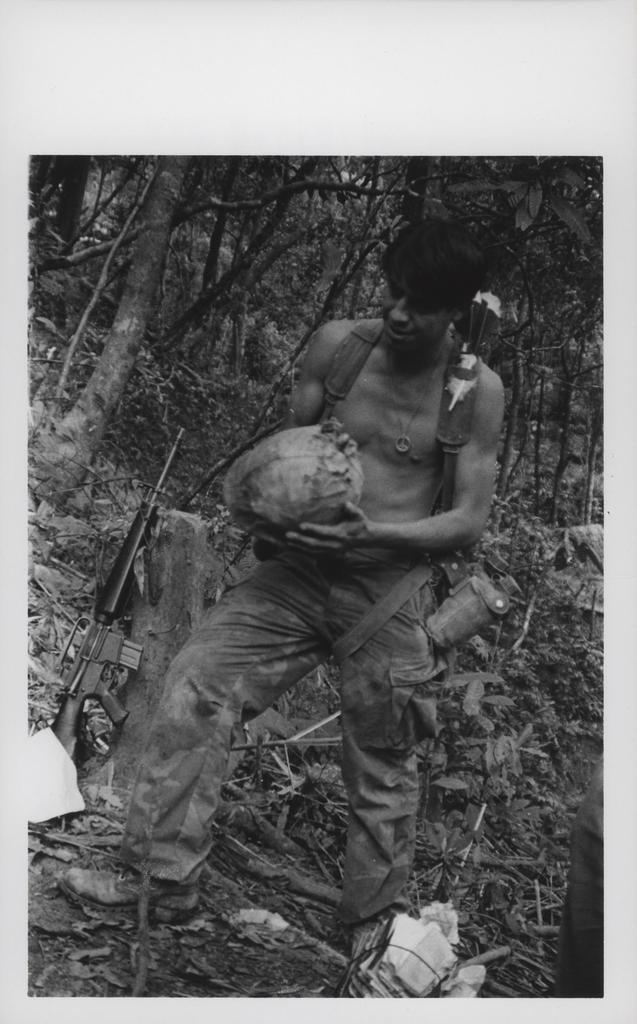What is the person in the image doing? The person is standing on the ground and holding an object. Can you describe the object the person is holding? Unfortunately, the facts provided do not specify the object the person is holding. What can be seen near the person in the image? There is a tree trunk and a gun beside the person. What is visible in the background of the image? There are trees in the background of the image. What type of produce is the lawyer discussing with the team in the image? There is no lawyer, team, or produce present in the image. 